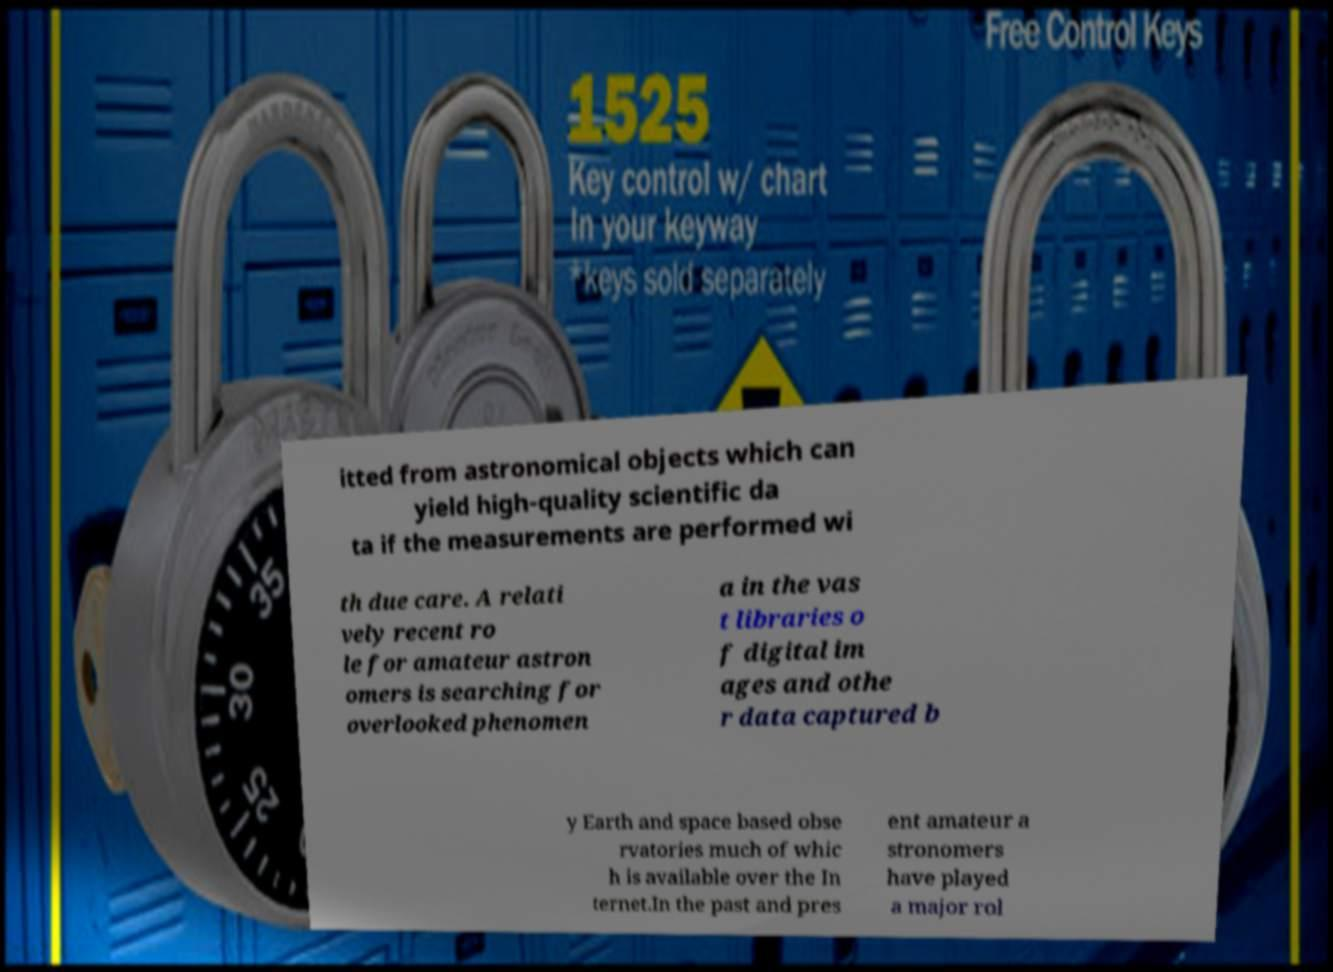I need the written content from this picture converted into text. Can you do that? itted from astronomical objects which can yield high-quality scientific da ta if the measurements are performed wi th due care. A relati vely recent ro le for amateur astron omers is searching for overlooked phenomen a in the vas t libraries o f digital im ages and othe r data captured b y Earth and space based obse rvatories much of whic h is available over the In ternet.In the past and pres ent amateur a stronomers have played a major rol 